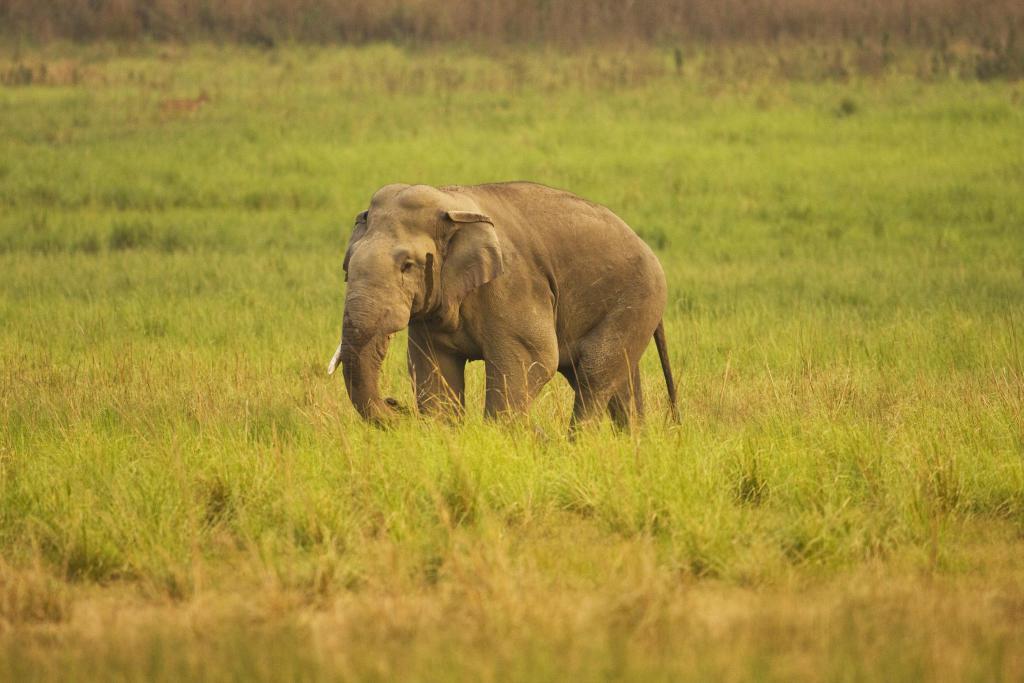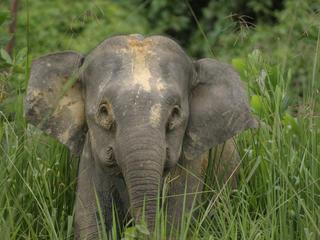The first image is the image on the left, the second image is the image on the right. Considering the images on both sides, is "There are two elephants" valid? Answer yes or no. Yes. 